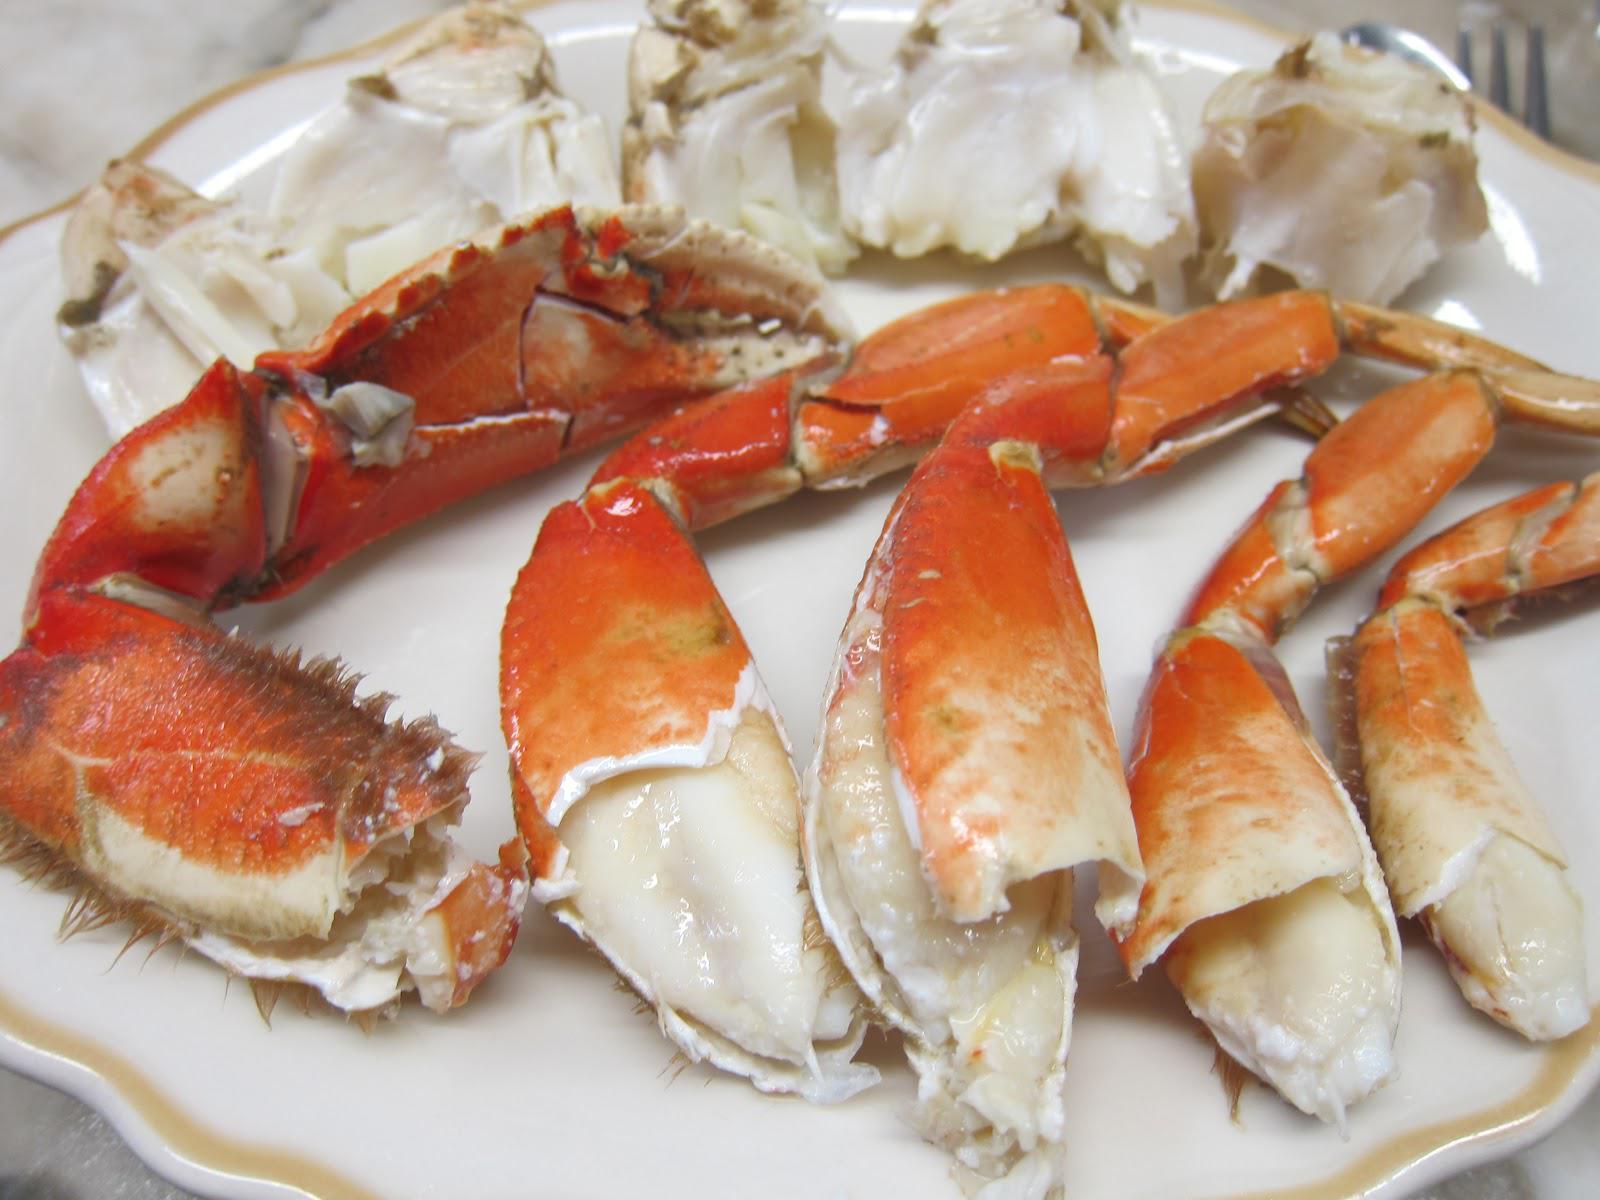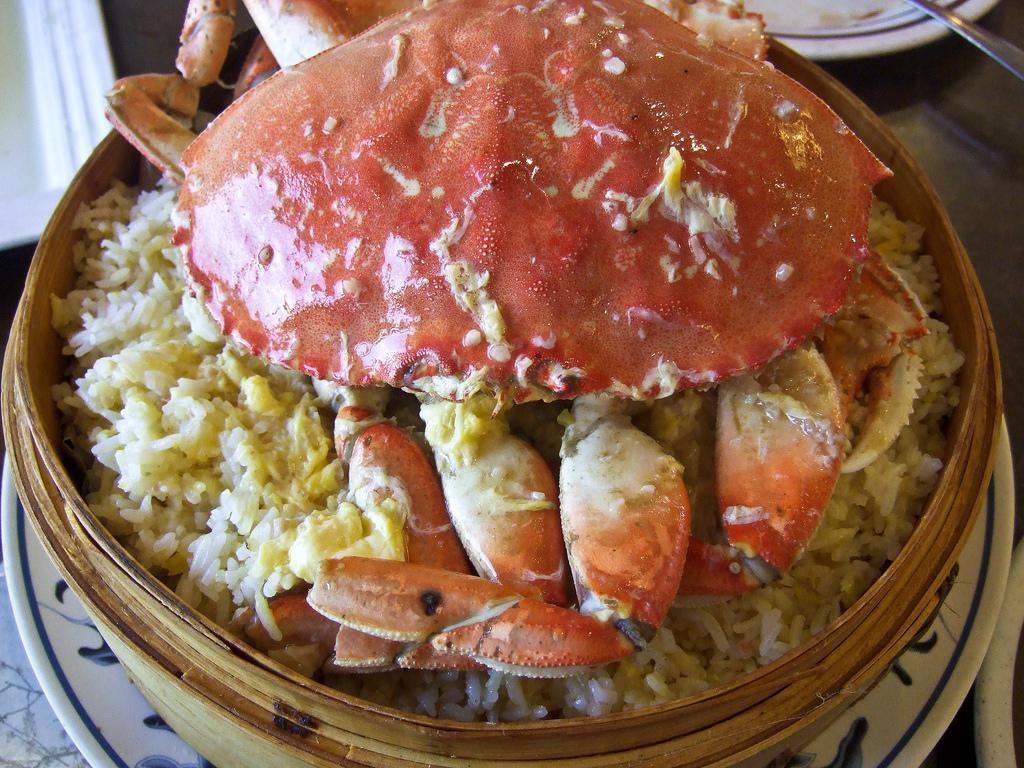The first image is the image on the left, the second image is the image on the right. Evaluate the accuracy of this statement regarding the images: "The left image shows a hollowed-out crab shell on a gold-rimmed plate with yellowish broth inside.". Is it true? Answer yes or no. No. 